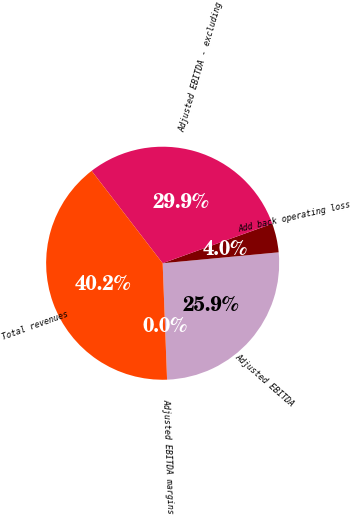Convert chart. <chart><loc_0><loc_0><loc_500><loc_500><pie_chart><fcel>Adjusted EBITDA<fcel>Add back operating loss<fcel>Adjusted EBITDA - excluding<fcel>Total revenues<fcel>Adjusted EBITDA margins<nl><fcel>25.89%<fcel>4.02%<fcel>29.91%<fcel>40.17%<fcel>0.0%<nl></chart> 